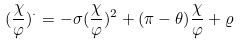<formula> <loc_0><loc_0><loc_500><loc_500>( \frac { \chi } { \varphi } ) ^ { \cdot } = - \sigma ( \frac { \chi } { \varphi } ) ^ { 2 } + ( \pi - \theta ) \frac { \chi } { \varphi } + \varrho</formula> 